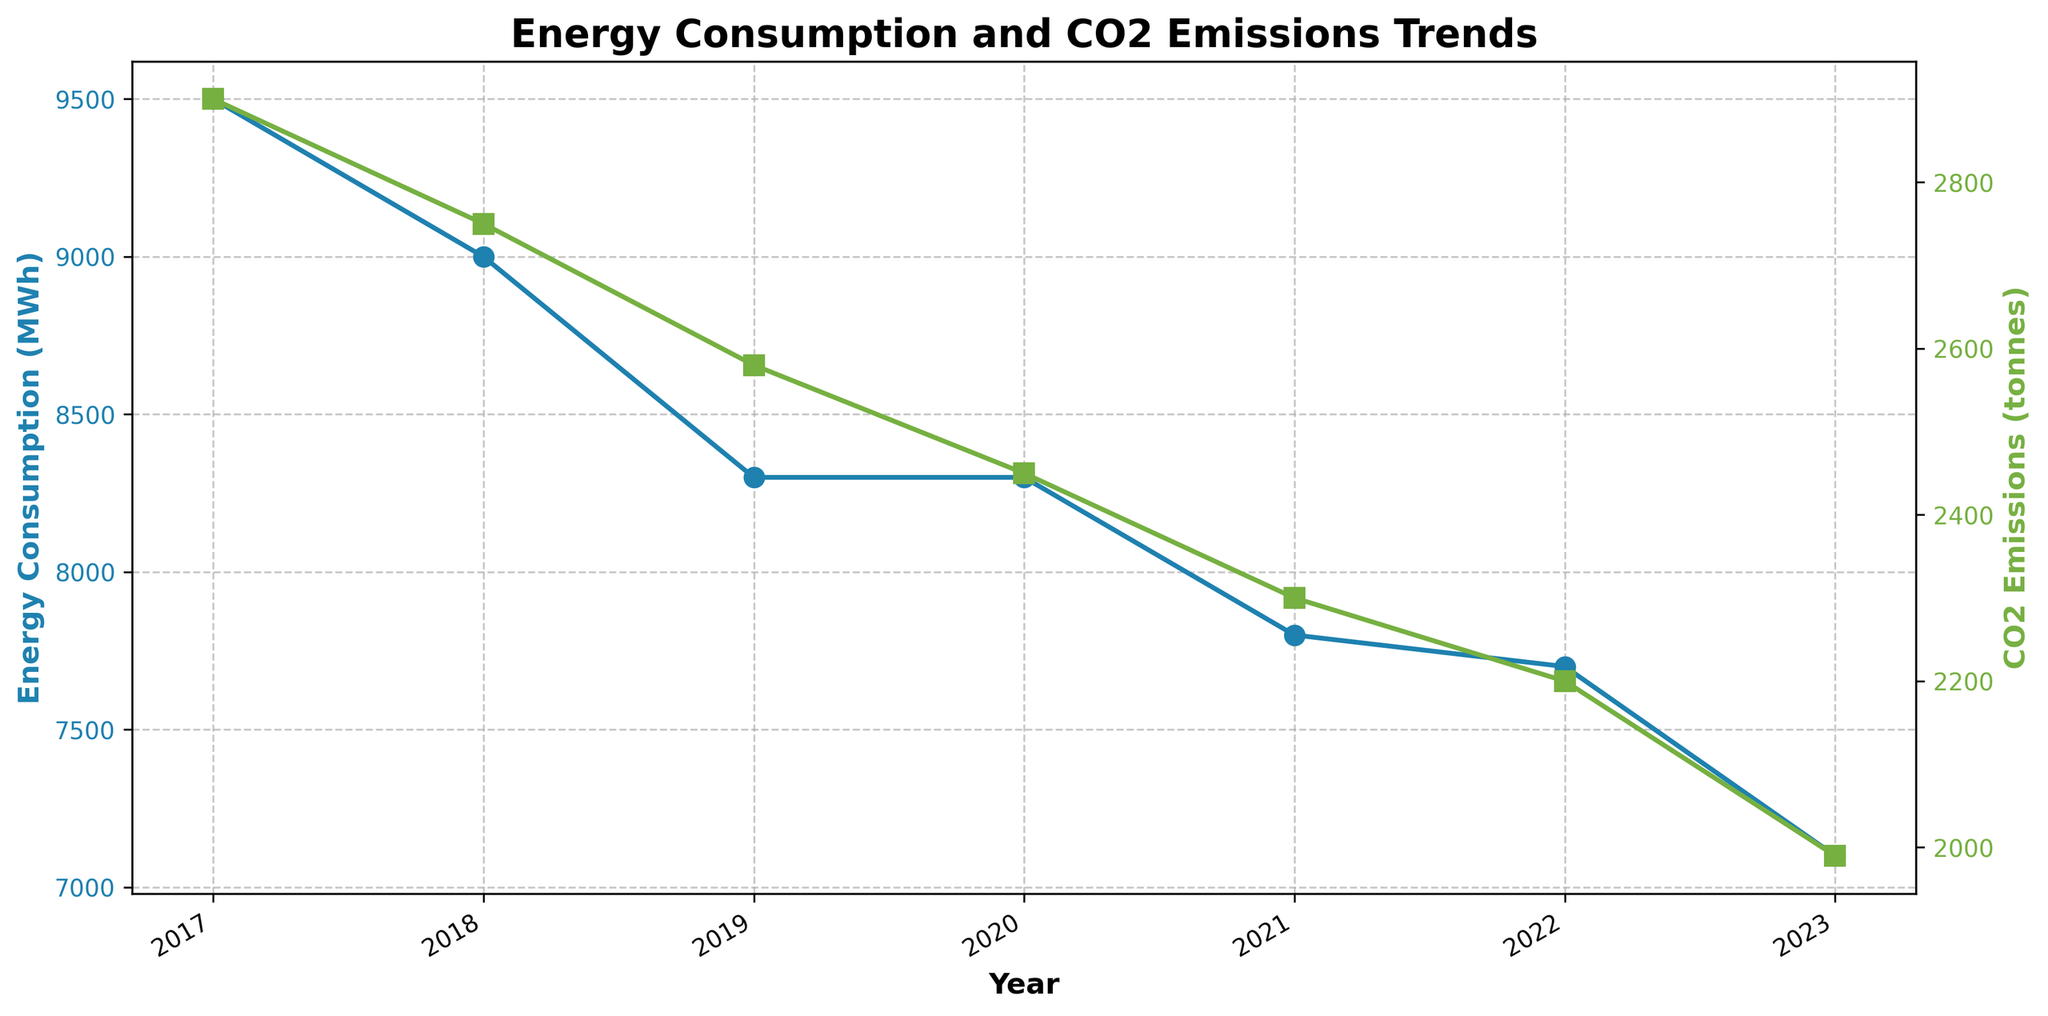What is the title of the plot? The title of the plot can be found at the top center of the figure. It provides a summary of what the plot represents.
Answer: Energy Consumption and CO2 Emissions Trends What are the units of measurement for energy consumption on the y-axis? The y-axis label for energy consumption indicates the units of measurement.
Answer: MWh How has the total energy consumption changed from 2017 to 2023? To determine this, look at the energy consumption values for 2017 and 2023 and compare them. The values are plotted with blue lines and markers.
Answer: It decreased What technology was implemented in 2020 and on which production line? You can find this information by looking at the annotations near the year 2020 on the plot.
Answer: High Efficiency Heating on Line D What was the total CO2 emissions in 2023? To find this, look at the green line and marker for the year 2023 on the right y-axis. The reading gives the total CO2 emissions.
Answer: 1,990 tonnes Which year had the lowest energy consumption? Look at the blue line to find the point with the lowest energy consumption value and identify the corresponding year on the x-axis.
Answer: 2023 Compare the energy consumption in 2018 and 2021. Which year was higher? Look at the blue line markers for years 2018 and 2021; compare their y-values.
Answer: 2018 was higher By how much did CO2 emissions decrease from 2017 to 2023? Subtract the CO2 emissions in 2023 from those in 2017 by referring to the green markers for these years.
Answer: 510 tonnes Which year saw the implementation of multiple technologies and what were they? Review the annotations for the years, and identify if more than one technology is listed for a particular year.
Answer: 2023, Solar Panels and Energy Management Systems How did the implementation of Energy Management Systems impact CO2 emissions over the years? Track the years when Energy Management Systems were implemented and observe the trend in CO2 emissions by looking at the green line on the plot.
Answer: CO2 emissions decreased 